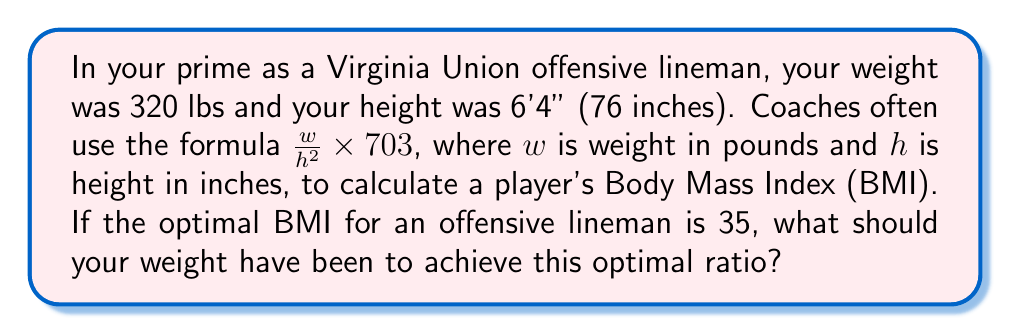Can you answer this question? Let's approach this step-by-step:

1) We're given the formula for BMI: 
   $BMI = \frac{w}{h^2} \times 703$

2) We know the optimal BMI is 35, and we know your height is 76 inches. Let's call the optimal weight $x$. We can set up the equation:

   $35 = \frac{x}{76^2} \times 703$

3) Let's solve for $x$:
   
   $35 = \frac{x}{5776} \times 703$
   
   $35 \times 5776 = x \times 703$
   
   $202160 = 703x$

4) Now we can divide both sides by 703:

   $\frac{202160}{703} = x$

5) Calculating this:

   $x \approx 287.57$

6) Since weight is typically measured in whole pounds, we'll round to the nearest pound:

   $x \approx 288$ lbs
Answer: 288 lbs 